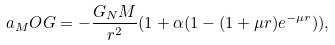<formula> <loc_0><loc_0><loc_500><loc_500>a _ { M } O G = - \frac { G _ { N } M } { r ^ { 2 } } ( 1 + \alpha ( 1 - ( 1 + \mu r ) e ^ { - \mu r } ) ) ,</formula> 